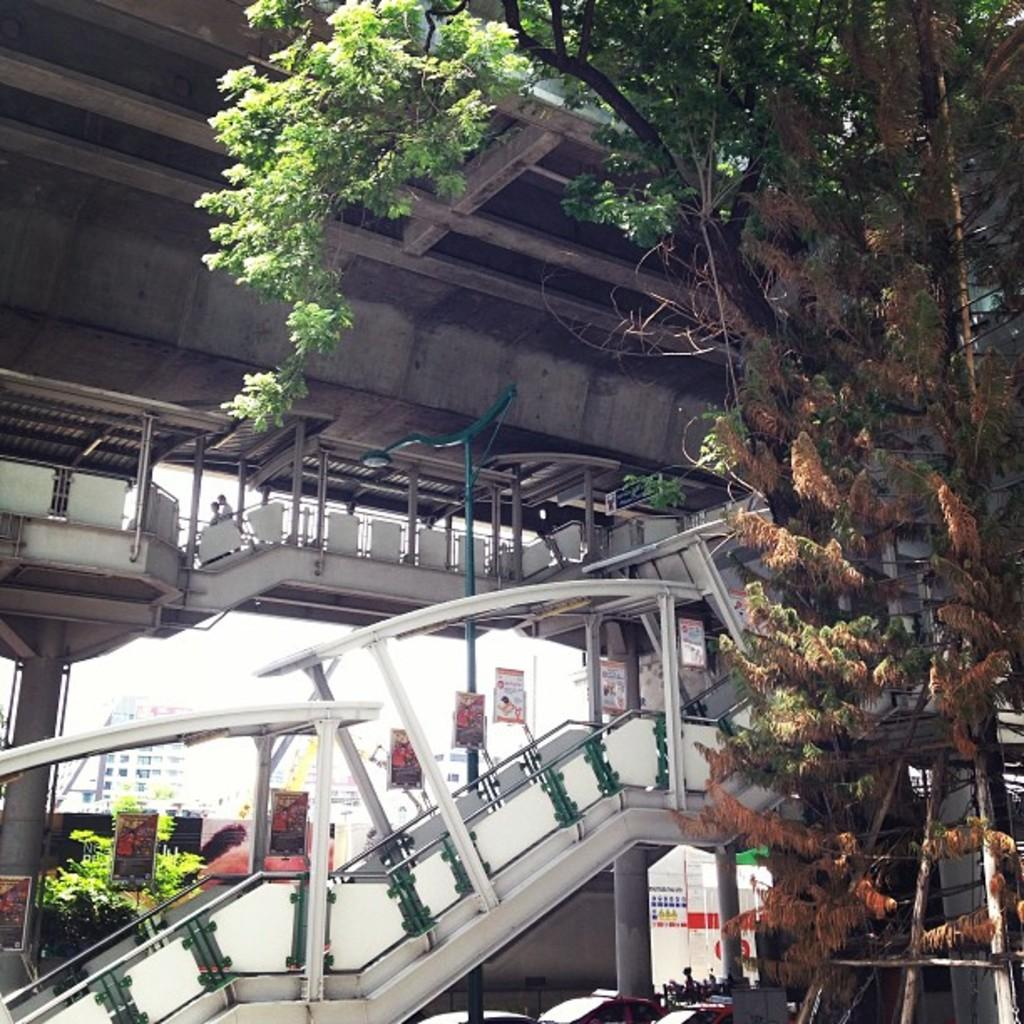What type of structure is present in the image? There is a staircase in the image. Where is the staircase located? The staircase is in a white corner. What can be seen beside the staircase in the right corner? There are trees beside the staircase in the right corner. What is above the staircase in the image? There is a bridge above the staircase. What type of toys are present on the bridge in the image? There are no toys present in the image, and the bridge does not have any toys on it. 